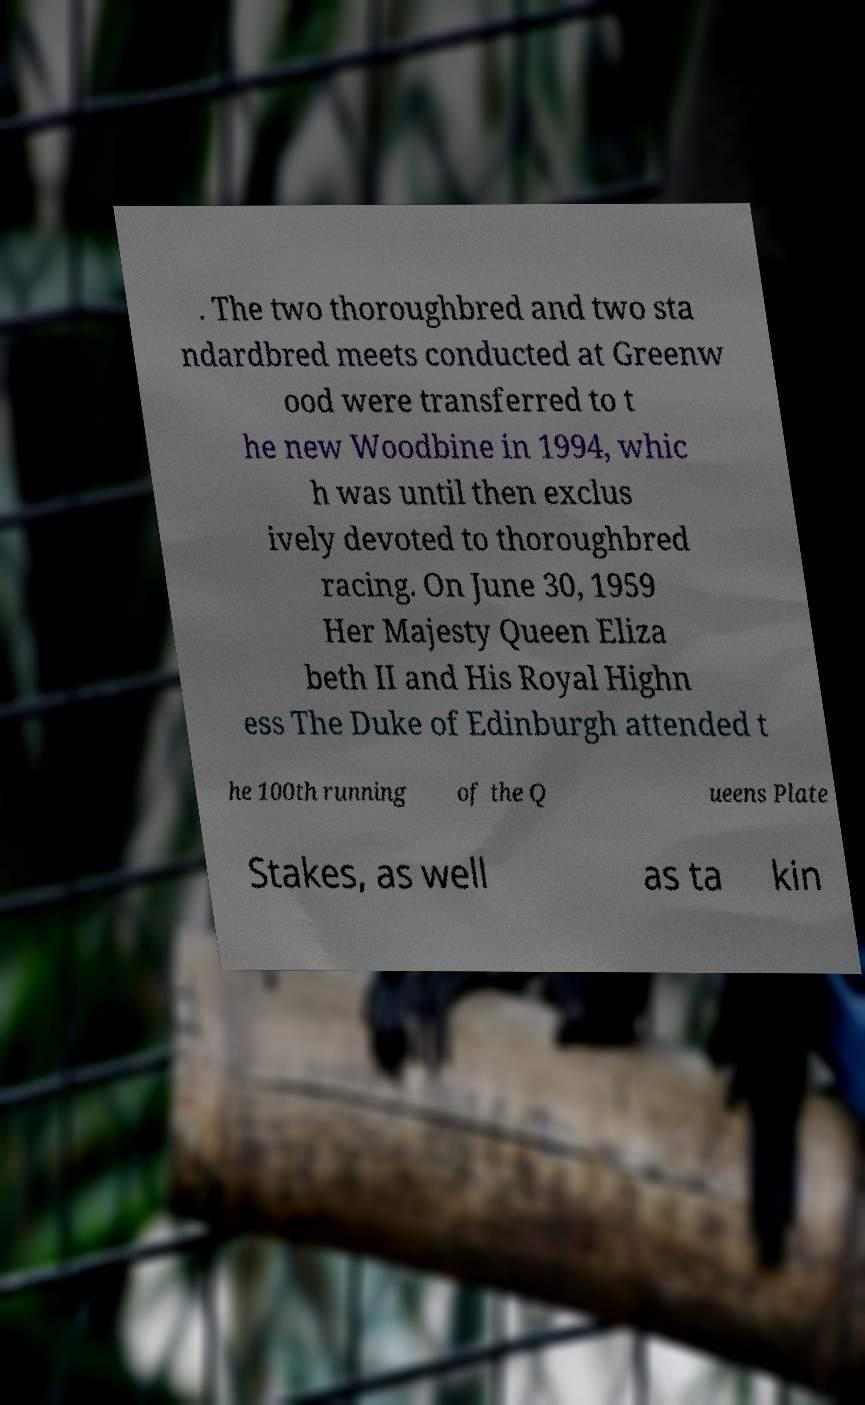Could you extract and type out the text from this image? . The two thoroughbred and two sta ndardbred meets conducted at Greenw ood were transferred to t he new Woodbine in 1994, whic h was until then exclus ively devoted to thoroughbred racing. On June 30, 1959 Her Majesty Queen Eliza beth II and His Royal Highn ess The Duke of Edinburgh attended t he 100th running of the Q ueens Plate Stakes, as well as ta kin 